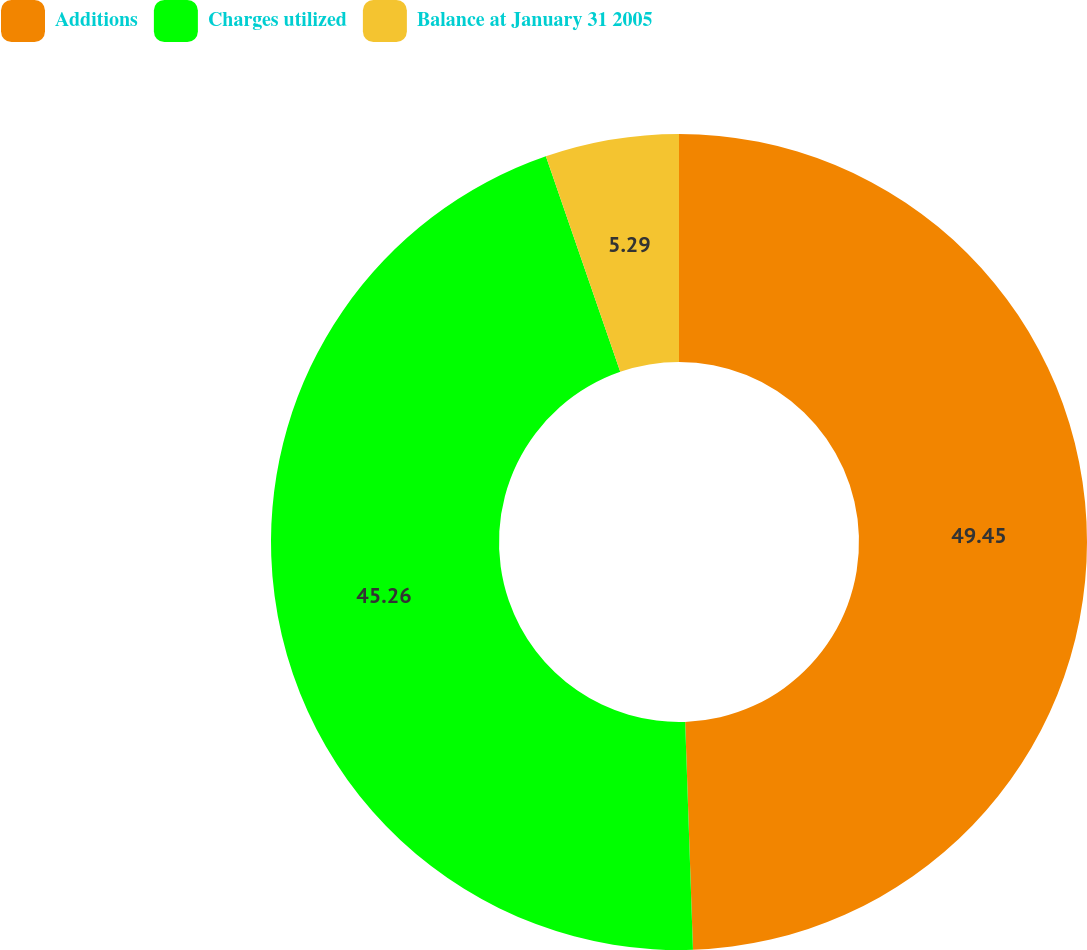Convert chart. <chart><loc_0><loc_0><loc_500><loc_500><pie_chart><fcel>Additions<fcel>Charges utilized<fcel>Balance at January 31 2005<nl><fcel>49.46%<fcel>45.26%<fcel>5.29%<nl></chart> 